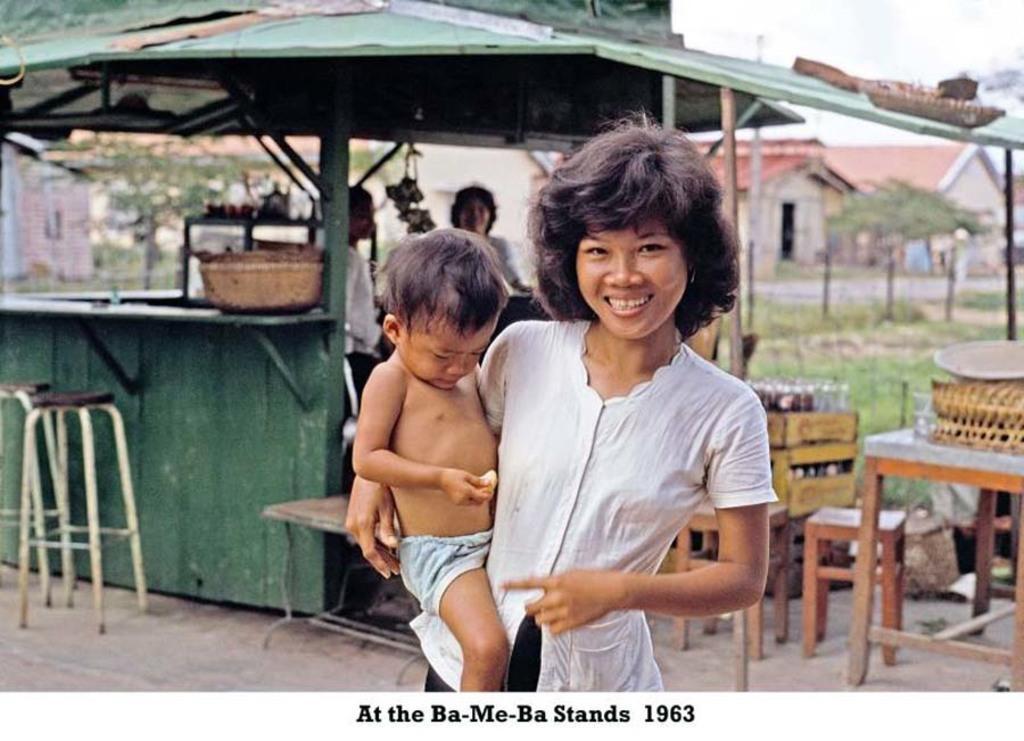Can you describe this image briefly? A woman is holding a baby and smiling. In the background there is a tent, stools, tables, trees. Also on the table there are some boxes and some other items. 